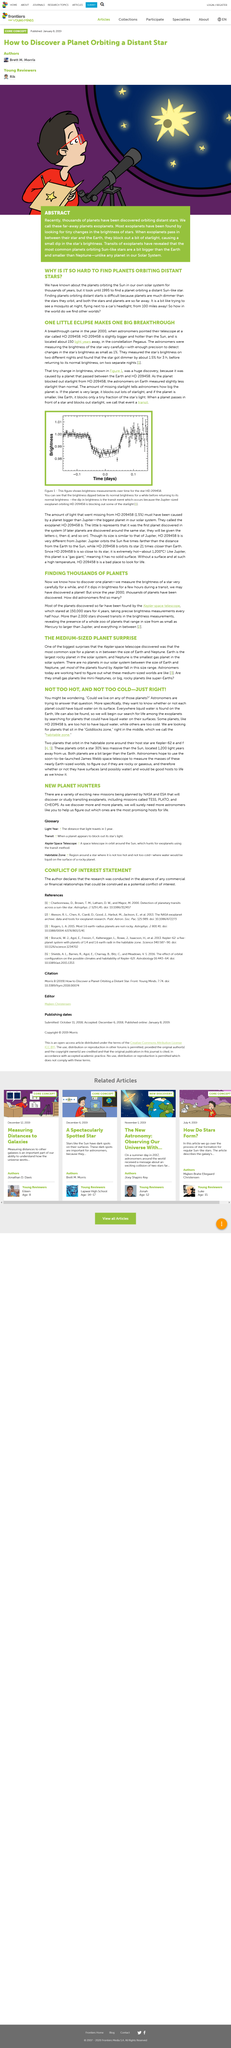Identify some key points in this picture. The habitable zone is commonly referred to as the Goldilocks zone because it is just right for supporting life as we know it. When a star's brightness dips, it suggests that a large object, likely a planet, is obstructing the star's path at that moment. HD 209458 is a star that is significantly larger and hotter than the sun, as it was found to be compared to the sun. The planet HD 209458 b is too hot to have water, making it an inhospitable world for life as we know it. The star HD 209458 is located 150 light years away from us. 